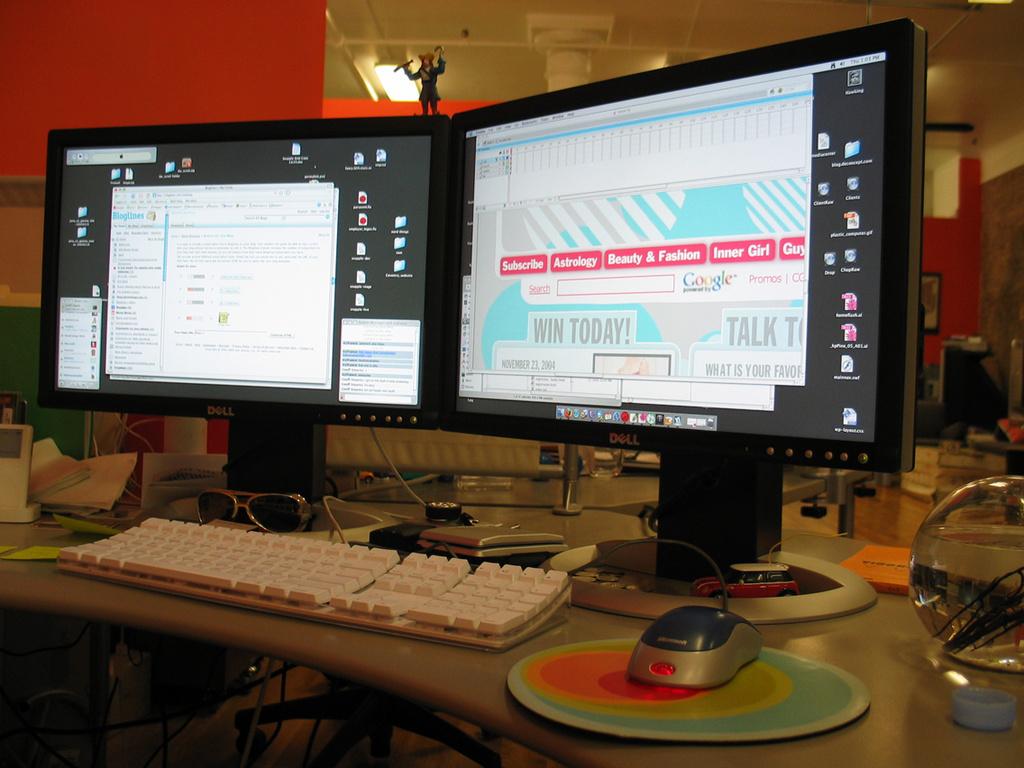What is the brand of the monitors?
Ensure brevity in your answer.  Dell. When can you "win"?
Provide a succinct answer. Today. 